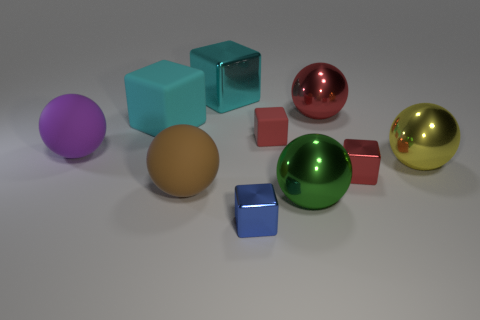Subtract all red metallic cubes. How many cubes are left? 4 Subtract all red cylinders. How many red blocks are left? 2 Subtract all purple spheres. How many spheres are left? 4 Subtract 0 purple cubes. How many objects are left? 10 Subtract 2 balls. How many balls are left? 3 Subtract all purple blocks. Subtract all brown spheres. How many blocks are left? 5 Subtract all small purple shiny spheres. Subtract all cyan objects. How many objects are left? 8 Add 4 large cyan objects. How many large cyan objects are left? 6 Add 1 large red matte cubes. How many large red matte cubes exist? 1 